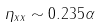Convert formula to latex. <formula><loc_0><loc_0><loc_500><loc_500>\eta _ { x x } \sim 0 . 2 3 5 \alpha</formula> 